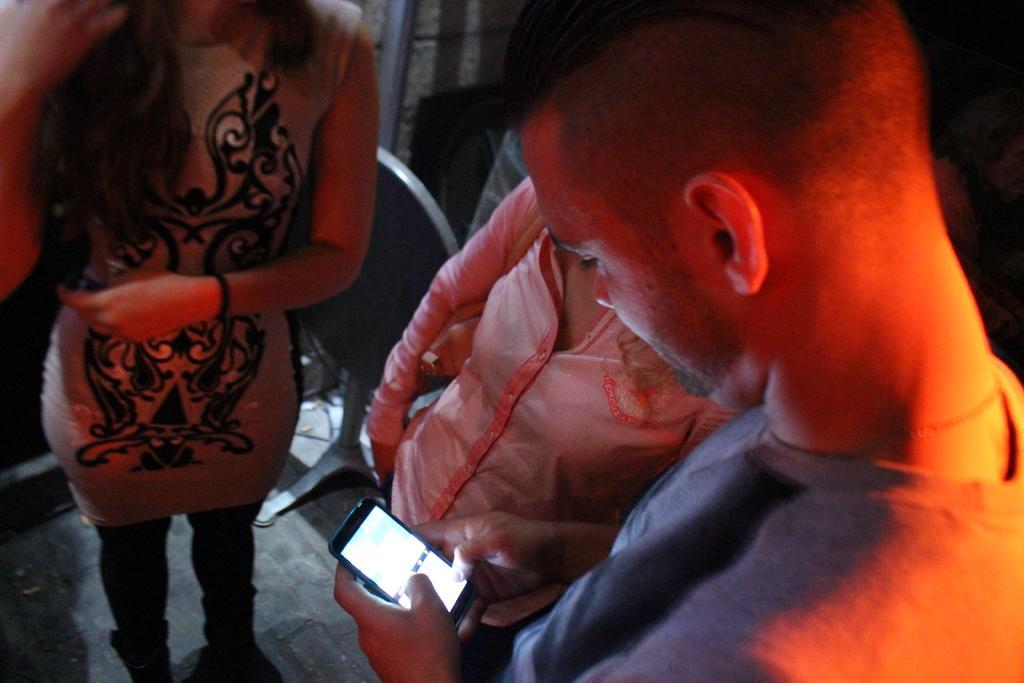Please provide a concise description of this image. In this picture we can see a man holding a mobile and looking at it. Beside him there are 2 women standing on the floor. In the background, we can see a chair and a wall. 